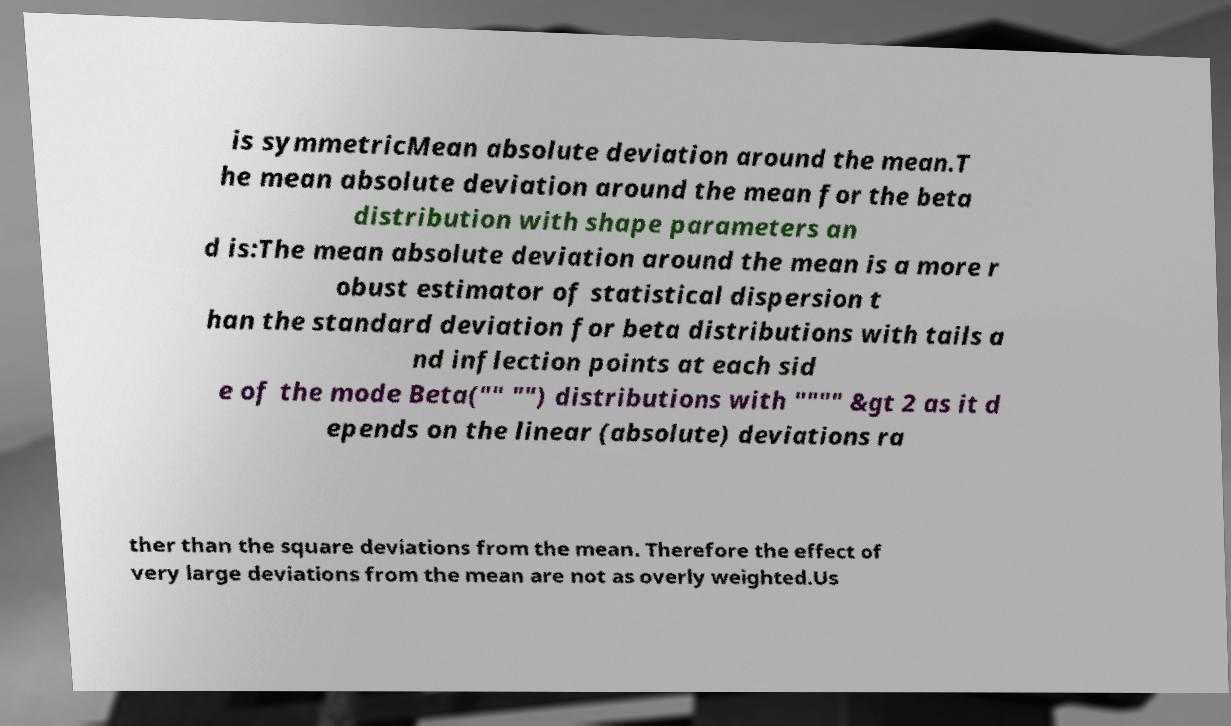Please read and relay the text visible in this image. What does it say? is symmetricMean absolute deviation around the mean.T he mean absolute deviation around the mean for the beta distribution with shape parameters an d is:The mean absolute deviation around the mean is a more r obust estimator of statistical dispersion t han the standard deviation for beta distributions with tails a nd inflection points at each sid e of the mode Beta("" "") distributions with """" &gt 2 as it d epends on the linear (absolute) deviations ra ther than the square deviations from the mean. Therefore the effect of very large deviations from the mean are not as overly weighted.Us 